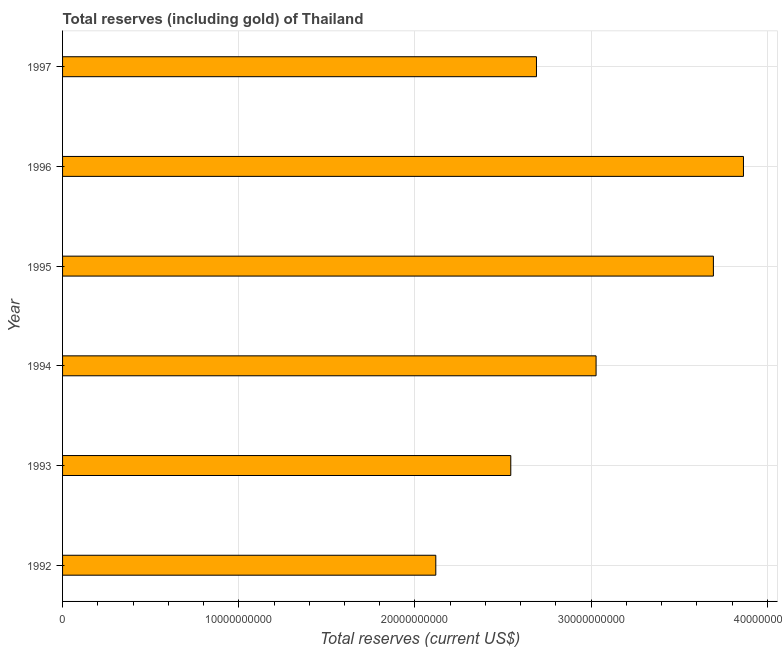Does the graph contain grids?
Make the answer very short. Yes. What is the title of the graph?
Give a very brief answer. Total reserves (including gold) of Thailand. What is the label or title of the X-axis?
Provide a short and direct response. Total reserves (current US$). What is the label or title of the Y-axis?
Your response must be concise. Year. What is the total reserves (including gold) in 1995?
Give a very brief answer. 3.69e+1. Across all years, what is the maximum total reserves (including gold)?
Provide a short and direct response. 3.86e+1. Across all years, what is the minimum total reserves (including gold)?
Your answer should be compact. 2.12e+1. In which year was the total reserves (including gold) maximum?
Provide a succinct answer. 1996. In which year was the total reserves (including gold) minimum?
Offer a very short reply. 1992. What is the sum of the total reserves (including gold)?
Give a very brief answer. 1.79e+11. What is the difference between the total reserves (including gold) in 1995 and 1996?
Ensure brevity in your answer.  -1.71e+09. What is the average total reserves (including gold) per year?
Make the answer very short. 2.99e+1. What is the median total reserves (including gold)?
Ensure brevity in your answer.  2.86e+1. What is the ratio of the total reserves (including gold) in 1992 to that in 1993?
Make the answer very short. 0.83. Is the total reserves (including gold) in 1993 less than that in 1997?
Make the answer very short. Yes. Is the difference between the total reserves (including gold) in 1995 and 1996 greater than the difference between any two years?
Your answer should be very brief. No. What is the difference between the highest and the second highest total reserves (including gold)?
Your answer should be compact. 1.71e+09. Is the sum of the total reserves (including gold) in 1995 and 1997 greater than the maximum total reserves (including gold) across all years?
Your answer should be very brief. Yes. What is the difference between the highest and the lowest total reserves (including gold)?
Provide a short and direct response. 1.75e+1. How many bars are there?
Keep it short and to the point. 6. Are all the bars in the graph horizontal?
Ensure brevity in your answer.  Yes. How many years are there in the graph?
Provide a short and direct response. 6. Are the values on the major ticks of X-axis written in scientific E-notation?
Offer a very short reply. No. What is the Total reserves (current US$) in 1992?
Provide a short and direct response. 2.12e+1. What is the Total reserves (current US$) of 1993?
Give a very brief answer. 2.54e+1. What is the Total reserves (current US$) of 1994?
Provide a short and direct response. 3.03e+1. What is the Total reserves (current US$) of 1995?
Your response must be concise. 3.69e+1. What is the Total reserves (current US$) of 1996?
Make the answer very short. 3.86e+1. What is the Total reserves (current US$) in 1997?
Offer a terse response. 2.69e+1. What is the difference between the Total reserves (current US$) in 1992 and 1993?
Offer a terse response. -4.26e+09. What is the difference between the Total reserves (current US$) in 1992 and 1994?
Your answer should be compact. -9.10e+09. What is the difference between the Total reserves (current US$) in 1992 and 1995?
Your response must be concise. -1.58e+1. What is the difference between the Total reserves (current US$) in 1992 and 1996?
Keep it short and to the point. -1.75e+1. What is the difference between the Total reserves (current US$) in 1992 and 1997?
Your answer should be compact. -5.71e+09. What is the difference between the Total reserves (current US$) in 1993 and 1994?
Ensure brevity in your answer.  -4.84e+09. What is the difference between the Total reserves (current US$) in 1993 and 1995?
Offer a terse response. -1.15e+1. What is the difference between the Total reserves (current US$) in 1993 and 1996?
Keep it short and to the point. -1.32e+1. What is the difference between the Total reserves (current US$) in 1993 and 1997?
Your answer should be very brief. -1.46e+09. What is the difference between the Total reserves (current US$) in 1994 and 1995?
Keep it short and to the point. -6.66e+09. What is the difference between the Total reserves (current US$) in 1994 and 1996?
Keep it short and to the point. -8.36e+09. What is the difference between the Total reserves (current US$) in 1994 and 1997?
Offer a very short reply. 3.38e+09. What is the difference between the Total reserves (current US$) in 1995 and 1996?
Keep it short and to the point. -1.71e+09. What is the difference between the Total reserves (current US$) in 1995 and 1997?
Keep it short and to the point. 1.00e+1. What is the difference between the Total reserves (current US$) in 1996 and 1997?
Your answer should be compact. 1.17e+1. What is the ratio of the Total reserves (current US$) in 1992 to that in 1993?
Your answer should be compact. 0.83. What is the ratio of the Total reserves (current US$) in 1992 to that in 1994?
Offer a very short reply. 0.7. What is the ratio of the Total reserves (current US$) in 1992 to that in 1995?
Provide a succinct answer. 0.57. What is the ratio of the Total reserves (current US$) in 1992 to that in 1996?
Provide a short and direct response. 0.55. What is the ratio of the Total reserves (current US$) in 1992 to that in 1997?
Your response must be concise. 0.79. What is the ratio of the Total reserves (current US$) in 1993 to that in 1994?
Your answer should be compact. 0.84. What is the ratio of the Total reserves (current US$) in 1993 to that in 1995?
Provide a succinct answer. 0.69. What is the ratio of the Total reserves (current US$) in 1993 to that in 1996?
Offer a very short reply. 0.66. What is the ratio of the Total reserves (current US$) in 1993 to that in 1997?
Give a very brief answer. 0.95. What is the ratio of the Total reserves (current US$) in 1994 to that in 1995?
Your response must be concise. 0.82. What is the ratio of the Total reserves (current US$) in 1994 to that in 1996?
Your response must be concise. 0.78. What is the ratio of the Total reserves (current US$) in 1994 to that in 1997?
Provide a short and direct response. 1.13. What is the ratio of the Total reserves (current US$) in 1995 to that in 1996?
Keep it short and to the point. 0.96. What is the ratio of the Total reserves (current US$) in 1995 to that in 1997?
Offer a very short reply. 1.37. What is the ratio of the Total reserves (current US$) in 1996 to that in 1997?
Make the answer very short. 1.44. 